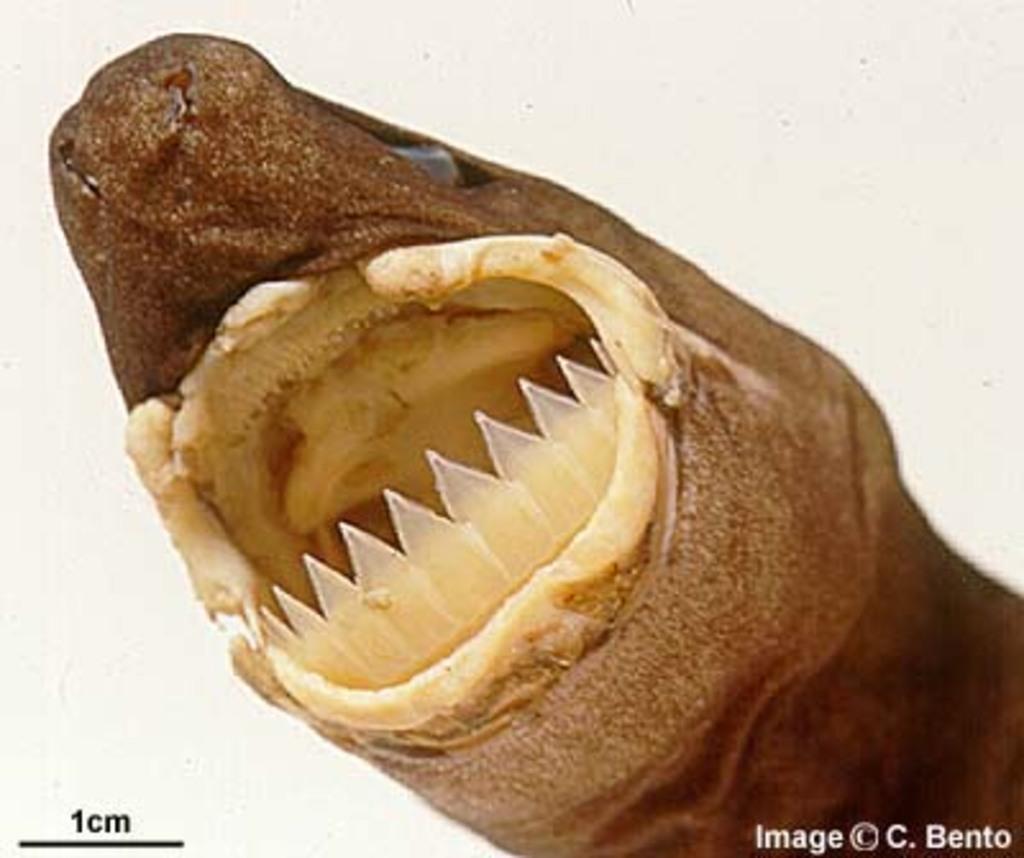Please provide a concise description of this image. In this image we can see a toy animal. In the background of the image there is a white background. On the image there is a watermark. 